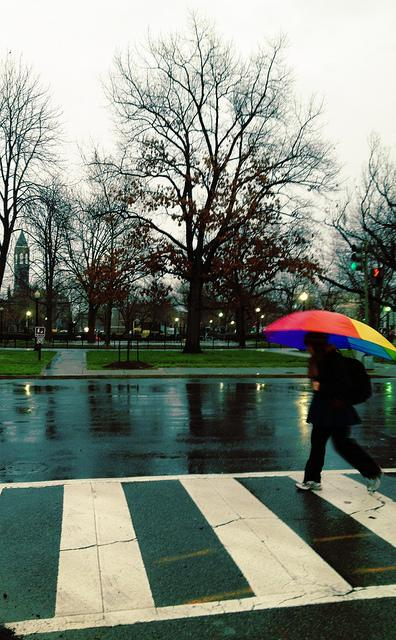What is the person with the umbrella walking on?

Choices:
A) stairs
B) sidewalk
C) escalator
D) zebra stripes zebra stripes 